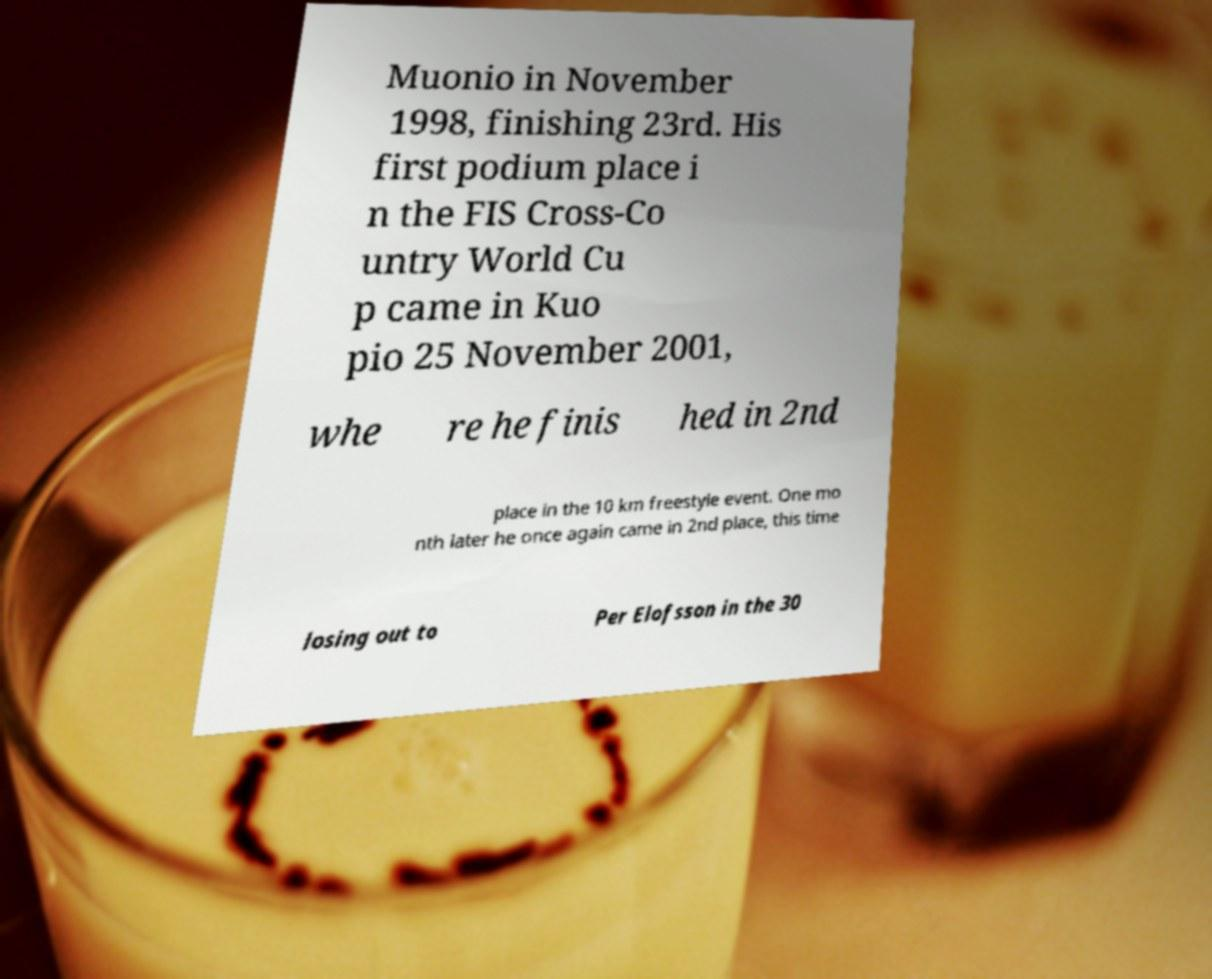Can you read and provide the text displayed in the image?This photo seems to have some interesting text. Can you extract and type it out for me? Muonio in November 1998, finishing 23rd. His first podium place i n the FIS Cross-Co untry World Cu p came in Kuo pio 25 November 2001, whe re he finis hed in 2nd place in the 10 km freestyle event. One mo nth later he once again came in 2nd place, this time losing out to Per Elofsson in the 30 